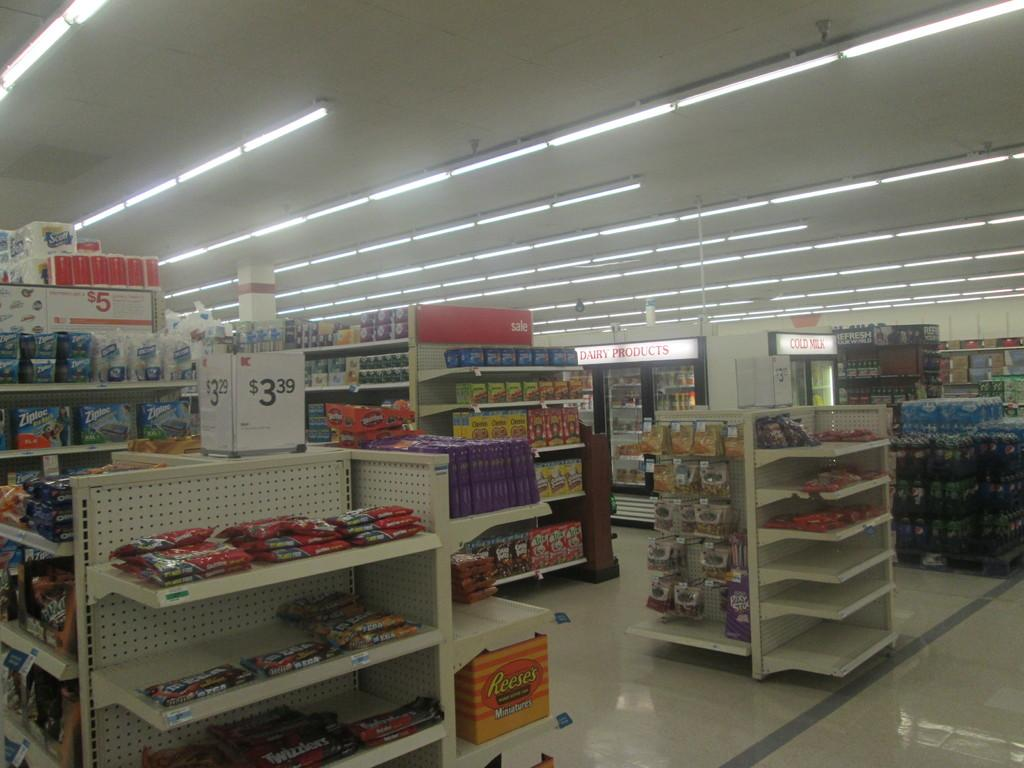<image>
Relay a brief, clear account of the picture shown. The inside of a store shows candy for sale for $3.39. 